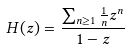Convert formula to latex. <formula><loc_0><loc_0><loc_500><loc_500>H ( z ) = \frac { \sum _ { n \geq 1 } \frac { 1 } { n } z ^ { n } } { 1 - z }</formula> 